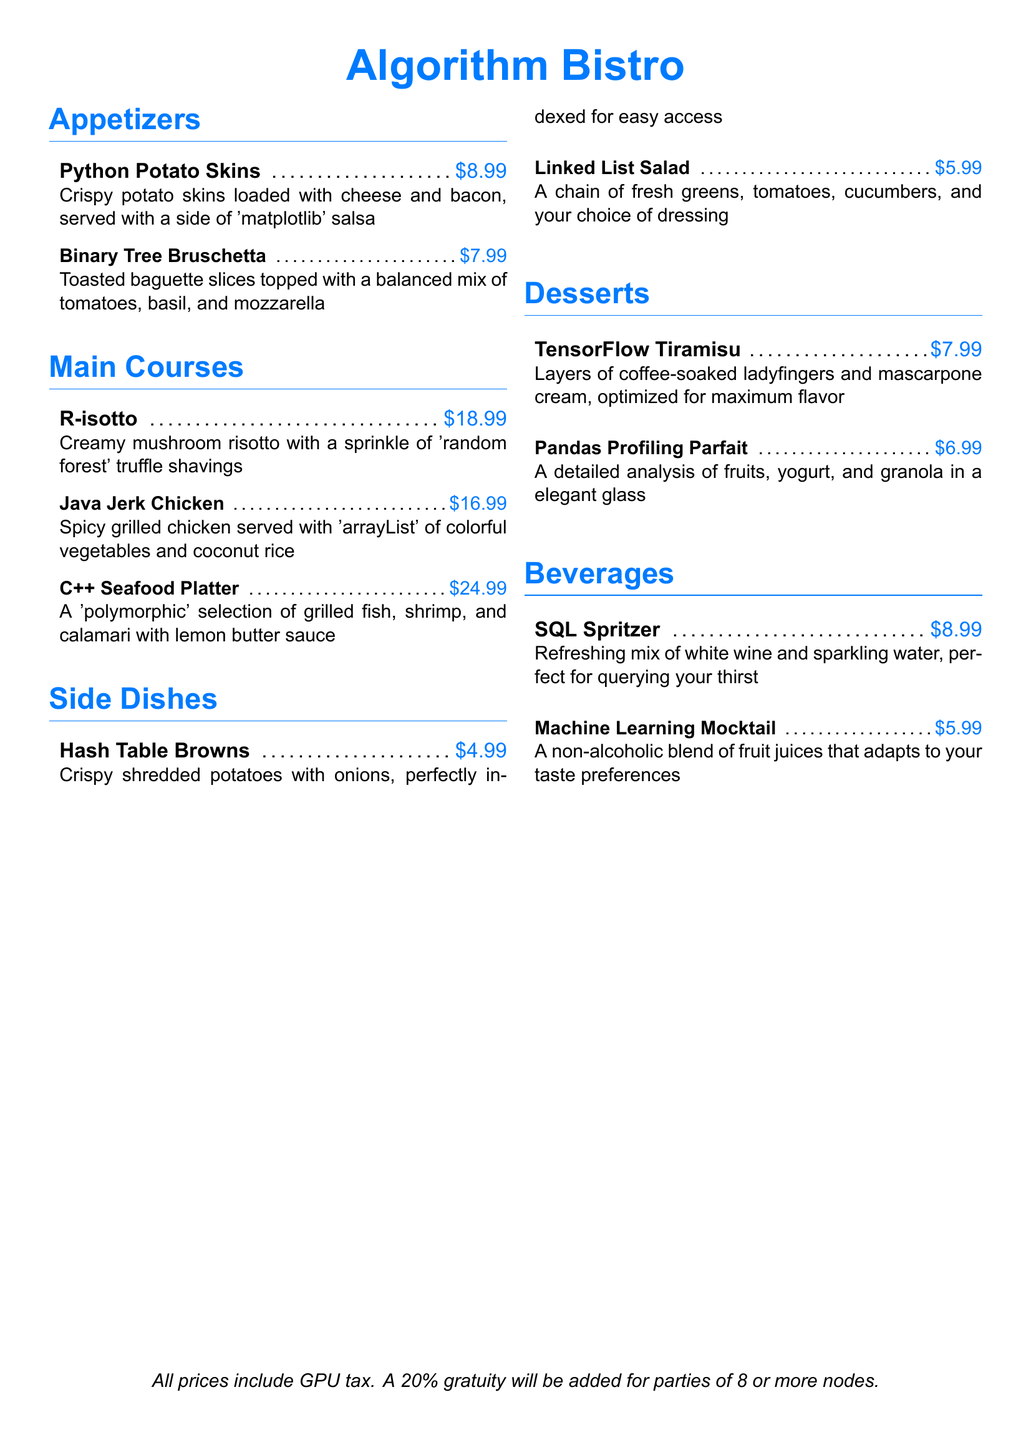What is the name of the restaurant? The document features a restaurant called "Algorithm Bistro."
Answer: Algorithm Bistro How much does the Python Potato Skins cost? The price listed for Python Potato Skins is $8.99.
Answer: $8.99 What is the main ingredient in R-isotto? The dish R-isotto is described as being made with creamy mushroom.
Answer: mushroom What side dish is indexed for easy access? The dish "Hash Table Browns" is described as "perfectly indexed for easy access."
Answer: Hash Table Browns Which dessert is optimized for maximum flavor? The dessert TensorFlow Tiramisu is explicitly described as being "optimized for maximum flavor."
Answer: TensorFlow Tiramisu How many appetizers are listed on the menu? There are a total of two appetizers mentioned in the document.
Answer: 2 What type of drink is the Machine Learning Mocktail? The Machine Learning Mocktail is a non-alcoholic drink.
Answer: non-alcoholic Which main course features a selection of seafood? The C++ Seafood Platter includes a selection of seafood.
Answer: C++ Seafood Platter What will be added for parties of eight or more nodes? A 20% gratuity will be added for parties of 8 or more nodes.
Answer: 20% gratuity 